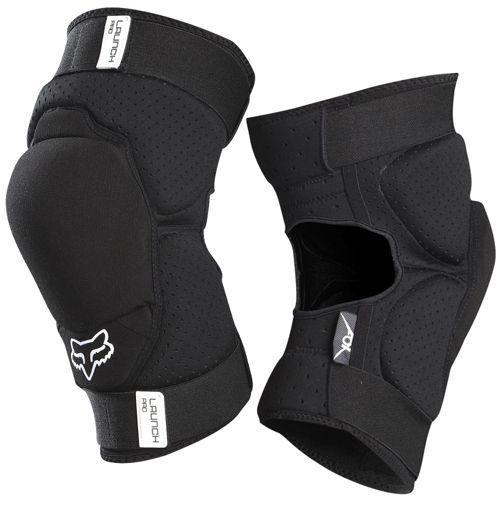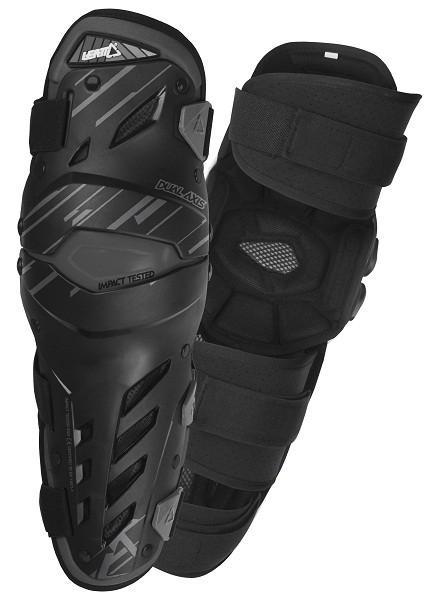The first image is the image on the left, the second image is the image on the right. Evaluate the accuracy of this statement regarding the images: "The image on the right contains both knee and shin guards.". Is it true? Answer yes or no. No. 